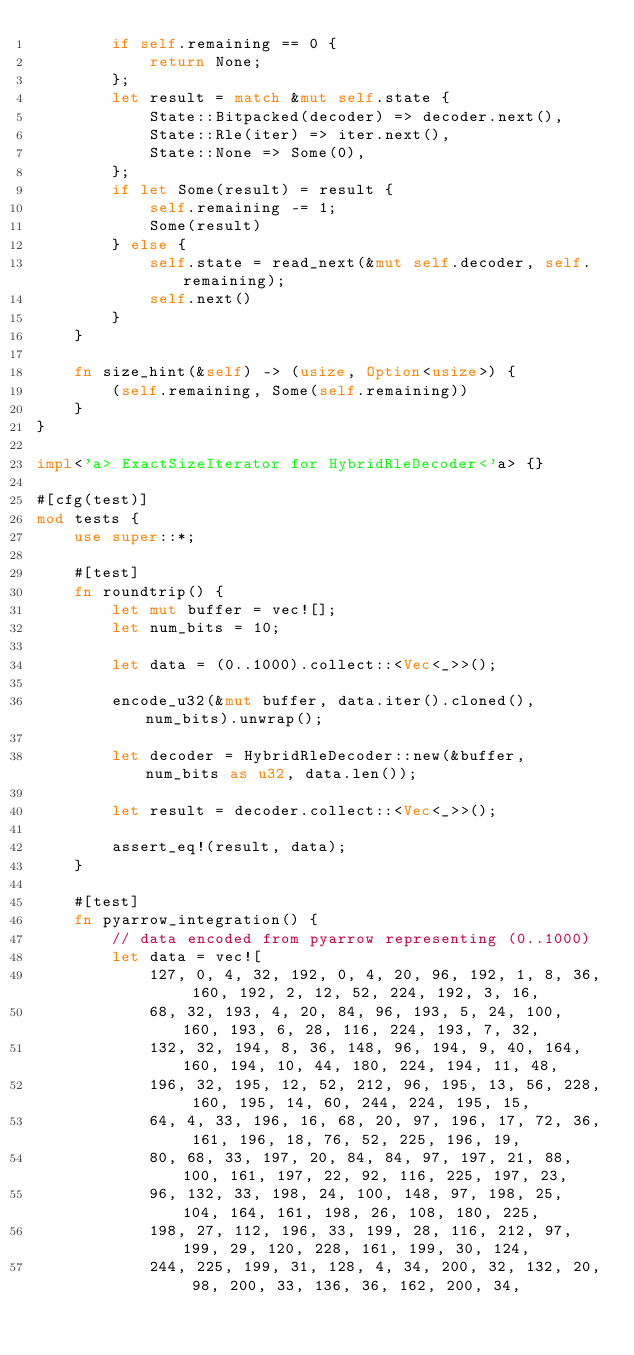<code> <loc_0><loc_0><loc_500><loc_500><_Rust_>        if self.remaining == 0 {
            return None;
        };
        let result = match &mut self.state {
            State::Bitpacked(decoder) => decoder.next(),
            State::Rle(iter) => iter.next(),
            State::None => Some(0),
        };
        if let Some(result) = result {
            self.remaining -= 1;
            Some(result)
        } else {
            self.state = read_next(&mut self.decoder, self.remaining);
            self.next()
        }
    }

    fn size_hint(&self) -> (usize, Option<usize>) {
        (self.remaining, Some(self.remaining))
    }
}

impl<'a> ExactSizeIterator for HybridRleDecoder<'a> {}

#[cfg(test)]
mod tests {
    use super::*;

    #[test]
    fn roundtrip() {
        let mut buffer = vec![];
        let num_bits = 10;

        let data = (0..1000).collect::<Vec<_>>();

        encode_u32(&mut buffer, data.iter().cloned(), num_bits).unwrap();

        let decoder = HybridRleDecoder::new(&buffer, num_bits as u32, data.len());

        let result = decoder.collect::<Vec<_>>();

        assert_eq!(result, data);
    }

    #[test]
    fn pyarrow_integration() {
        // data encoded from pyarrow representing (0..1000)
        let data = vec![
            127, 0, 4, 32, 192, 0, 4, 20, 96, 192, 1, 8, 36, 160, 192, 2, 12, 52, 224, 192, 3, 16,
            68, 32, 193, 4, 20, 84, 96, 193, 5, 24, 100, 160, 193, 6, 28, 116, 224, 193, 7, 32,
            132, 32, 194, 8, 36, 148, 96, 194, 9, 40, 164, 160, 194, 10, 44, 180, 224, 194, 11, 48,
            196, 32, 195, 12, 52, 212, 96, 195, 13, 56, 228, 160, 195, 14, 60, 244, 224, 195, 15,
            64, 4, 33, 196, 16, 68, 20, 97, 196, 17, 72, 36, 161, 196, 18, 76, 52, 225, 196, 19,
            80, 68, 33, 197, 20, 84, 84, 97, 197, 21, 88, 100, 161, 197, 22, 92, 116, 225, 197, 23,
            96, 132, 33, 198, 24, 100, 148, 97, 198, 25, 104, 164, 161, 198, 26, 108, 180, 225,
            198, 27, 112, 196, 33, 199, 28, 116, 212, 97, 199, 29, 120, 228, 161, 199, 30, 124,
            244, 225, 199, 31, 128, 4, 34, 200, 32, 132, 20, 98, 200, 33, 136, 36, 162, 200, 34,</code> 